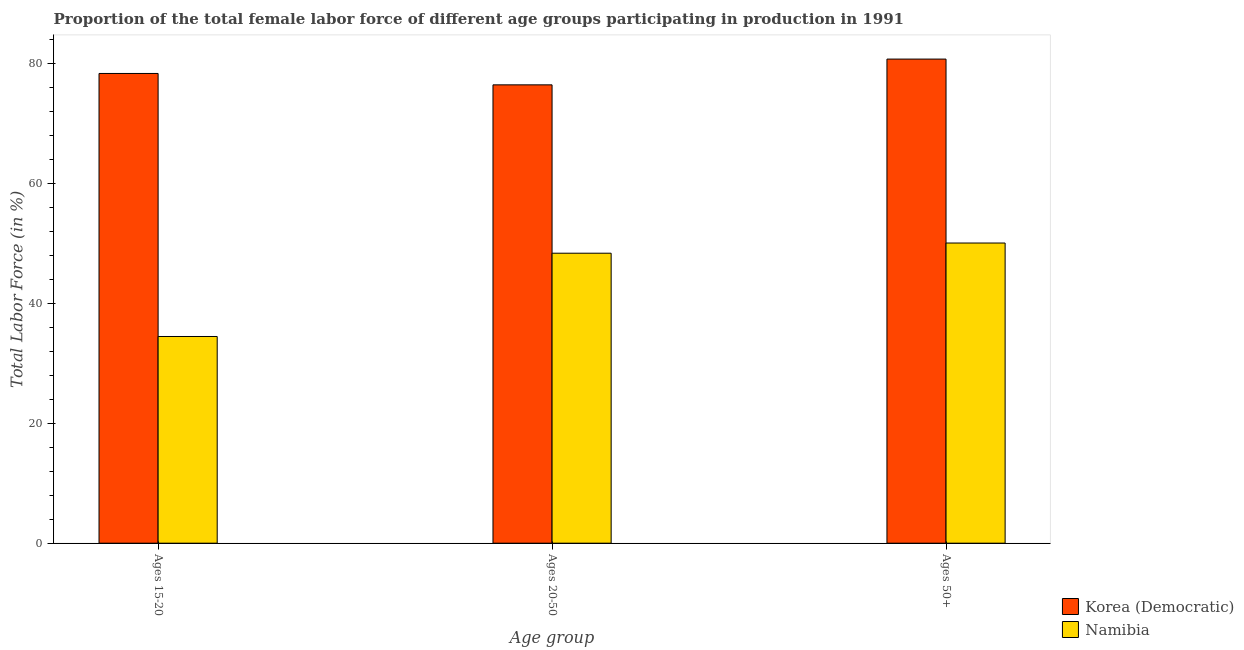Are the number of bars per tick equal to the number of legend labels?
Your answer should be very brief. Yes. What is the label of the 2nd group of bars from the left?
Make the answer very short. Ages 20-50. What is the percentage of female labor force within the age group 15-20 in Korea (Democratic)?
Provide a short and direct response. 78.4. Across all countries, what is the maximum percentage of female labor force above age 50?
Give a very brief answer. 80.8. Across all countries, what is the minimum percentage of female labor force above age 50?
Provide a succinct answer. 50.1. In which country was the percentage of female labor force above age 50 maximum?
Provide a short and direct response. Korea (Democratic). In which country was the percentage of female labor force within the age group 15-20 minimum?
Offer a terse response. Namibia. What is the total percentage of female labor force above age 50 in the graph?
Your answer should be compact. 130.9. What is the difference between the percentage of female labor force within the age group 20-50 in Korea (Democratic) and that in Namibia?
Offer a terse response. 28.1. What is the difference between the percentage of female labor force within the age group 15-20 in Namibia and the percentage of female labor force above age 50 in Korea (Democratic)?
Make the answer very short. -46.3. What is the average percentage of female labor force within the age group 20-50 per country?
Make the answer very short. 62.45. What is the difference between the percentage of female labor force within the age group 15-20 and percentage of female labor force above age 50 in Namibia?
Keep it short and to the point. -15.6. In how many countries, is the percentage of female labor force above age 50 greater than 68 %?
Offer a very short reply. 1. What is the ratio of the percentage of female labor force within the age group 15-20 in Korea (Democratic) to that in Namibia?
Your response must be concise. 2.27. Is the percentage of female labor force within the age group 15-20 in Korea (Democratic) less than that in Namibia?
Make the answer very short. No. What is the difference between the highest and the second highest percentage of female labor force within the age group 15-20?
Provide a short and direct response. 43.9. What is the difference between the highest and the lowest percentage of female labor force within the age group 20-50?
Give a very brief answer. 28.1. In how many countries, is the percentage of female labor force above age 50 greater than the average percentage of female labor force above age 50 taken over all countries?
Offer a very short reply. 1. What does the 1st bar from the left in Ages 50+ represents?
Your response must be concise. Korea (Democratic). What does the 2nd bar from the right in Ages 15-20 represents?
Offer a very short reply. Korea (Democratic). Is it the case that in every country, the sum of the percentage of female labor force within the age group 15-20 and percentage of female labor force within the age group 20-50 is greater than the percentage of female labor force above age 50?
Your answer should be compact. Yes. Are the values on the major ticks of Y-axis written in scientific E-notation?
Your answer should be very brief. No. Where does the legend appear in the graph?
Provide a succinct answer. Bottom right. How many legend labels are there?
Provide a short and direct response. 2. What is the title of the graph?
Your response must be concise. Proportion of the total female labor force of different age groups participating in production in 1991. What is the label or title of the X-axis?
Your answer should be very brief. Age group. What is the Total Labor Force (in %) in Korea (Democratic) in Ages 15-20?
Make the answer very short. 78.4. What is the Total Labor Force (in %) of Namibia in Ages 15-20?
Make the answer very short. 34.5. What is the Total Labor Force (in %) in Korea (Democratic) in Ages 20-50?
Provide a short and direct response. 76.5. What is the Total Labor Force (in %) of Namibia in Ages 20-50?
Give a very brief answer. 48.4. What is the Total Labor Force (in %) in Korea (Democratic) in Ages 50+?
Offer a terse response. 80.8. What is the Total Labor Force (in %) in Namibia in Ages 50+?
Give a very brief answer. 50.1. Across all Age group, what is the maximum Total Labor Force (in %) of Korea (Democratic)?
Provide a short and direct response. 80.8. Across all Age group, what is the maximum Total Labor Force (in %) in Namibia?
Provide a succinct answer. 50.1. Across all Age group, what is the minimum Total Labor Force (in %) of Korea (Democratic)?
Offer a very short reply. 76.5. Across all Age group, what is the minimum Total Labor Force (in %) in Namibia?
Your response must be concise. 34.5. What is the total Total Labor Force (in %) of Korea (Democratic) in the graph?
Make the answer very short. 235.7. What is the total Total Labor Force (in %) of Namibia in the graph?
Provide a short and direct response. 133. What is the difference between the Total Labor Force (in %) in Korea (Democratic) in Ages 15-20 and that in Ages 20-50?
Your response must be concise. 1.9. What is the difference between the Total Labor Force (in %) of Namibia in Ages 15-20 and that in Ages 20-50?
Keep it short and to the point. -13.9. What is the difference between the Total Labor Force (in %) in Namibia in Ages 15-20 and that in Ages 50+?
Ensure brevity in your answer.  -15.6. What is the difference between the Total Labor Force (in %) of Korea (Democratic) in Ages 20-50 and that in Ages 50+?
Your answer should be compact. -4.3. What is the difference between the Total Labor Force (in %) in Namibia in Ages 20-50 and that in Ages 50+?
Your answer should be very brief. -1.7. What is the difference between the Total Labor Force (in %) in Korea (Democratic) in Ages 15-20 and the Total Labor Force (in %) in Namibia in Ages 50+?
Give a very brief answer. 28.3. What is the difference between the Total Labor Force (in %) of Korea (Democratic) in Ages 20-50 and the Total Labor Force (in %) of Namibia in Ages 50+?
Provide a short and direct response. 26.4. What is the average Total Labor Force (in %) of Korea (Democratic) per Age group?
Keep it short and to the point. 78.57. What is the average Total Labor Force (in %) in Namibia per Age group?
Offer a very short reply. 44.33. What is the difference between the Total Labor Force (in %) in Korea (Democratic) and Total Labor Force (in %) in Namibia in Ages 15-20?
Offer a very short reply. 43.9. What is the difference between the Total Labor Force (in %) of Korea (Democratic) and Total Labor Force (in %) of Namibia in Ages 20-50?
Keep it short and to the point. 28.1. What is the difference between the Total Labor Force (in %) of Korea (Democratic) and Total Labor Force (in %) of Namibia in Ages 50+?
Your answer should be very brief. 30.7. What is the ratio of the Total Labor Force (in %) in Korea (Democratic) in Ages 15-20 to that in Ages 20-50?
Your answer should be very brief. 1.02. What is the ratio of the Total Labor Force (in %) in Namibia in Ages 15-20 to that in Ages 20-50?
Your answer should be very brief. 0.71. What is the ratio of the Total Labor Force (in %) of Korea (Democratic) in Ages 15-20 to that in Ages 50+?
Your answer should be compact. 0.97. What is the ratio of the Total Labor Force (in %) in Namibia in Ages 15-20 to that in Ages 50+?
Provide a short and direct response. 0.69. What is the ratio of the Total Labor Force (in %) of Korea (Democratic) in Ages 20-50 to that in Ages 50+?
Your answer should be compact. 0.95. What is the ratio of the Total Labor Force (in %) in Namibia in Ages 20-50 to that in Ages 50+?
Make the answer very short. 0.97. What is the difference between the highest and the second highest Total Labor Force (in %) in Korea (Democratic)?
Your response must be concise. 2.4. What is the difference between the highest and the lowest Total Labor Force (in %) in Korea (Democratic)?
Offer a very short reply. 4.3. What is the difference between the highest and the lowest Total Labor Force (in %) in Namibia?
Provide a succinct answer. 15.6. 